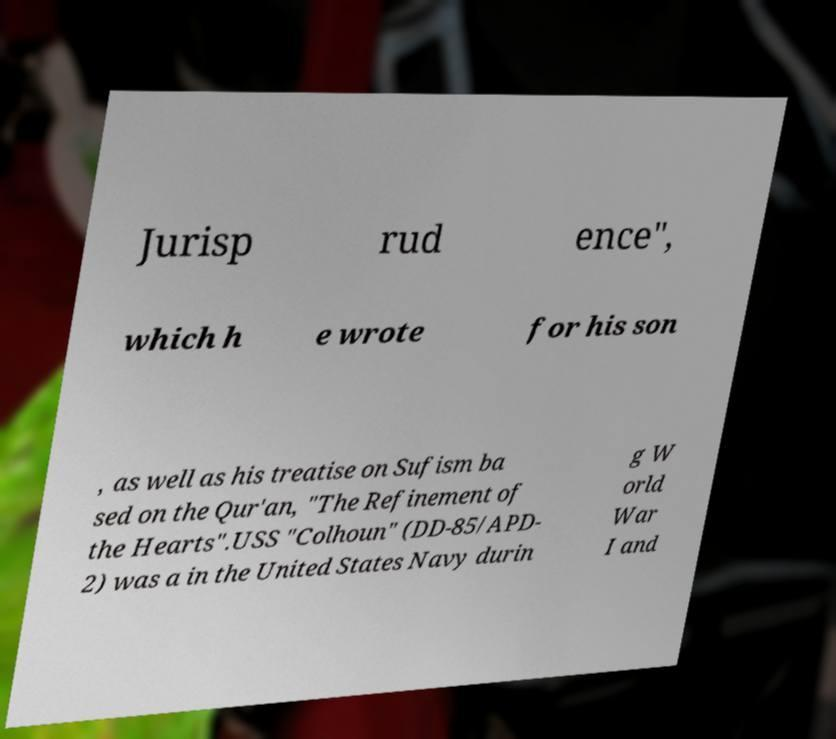For documentation purposes, I need the text within this image transcribed. Could you provide that? Jurisp rud ence", which h e wrote for his son , as well as his treatise on Sufism ba sed on the Qur'an, "The Refinement of the Hearts".USS "Colhoun" (DD-85/APD- 2) was a in the United States Navy durin g W orld War I and 